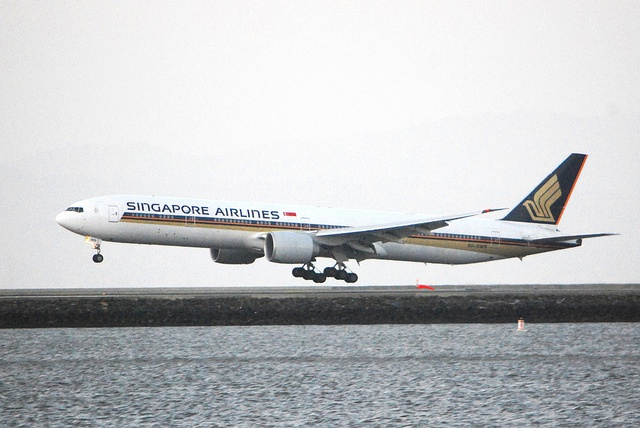Describe the objects in this image and their specific colors. I can see a airplane in lightgray, white, gray, darkgray, and black tones in this image. 